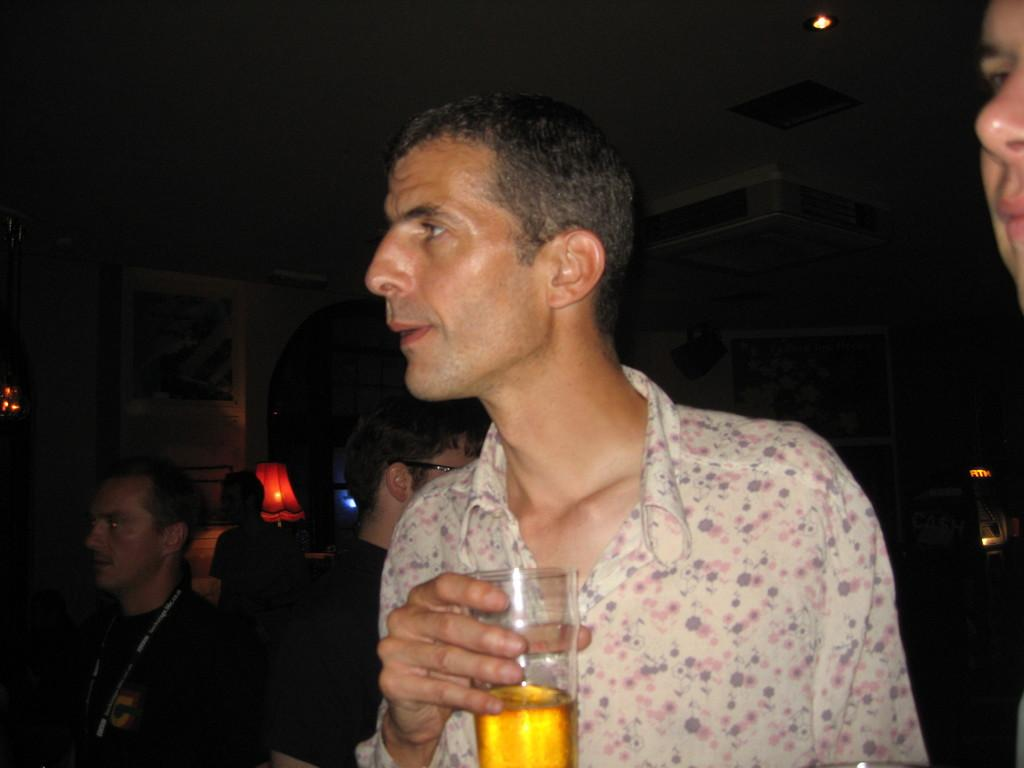What is the man in the image doing with his hand? The man is holding a glass with his hand. How many people are present in the image? There are three persons in the image. What can be seen on the wall in the image? There is a lamp on the wall in the image. What type of hen can be seen sitting on the lamp in the image? There is no hen present in the image, and the lamp is not a place where a hen would sit. 